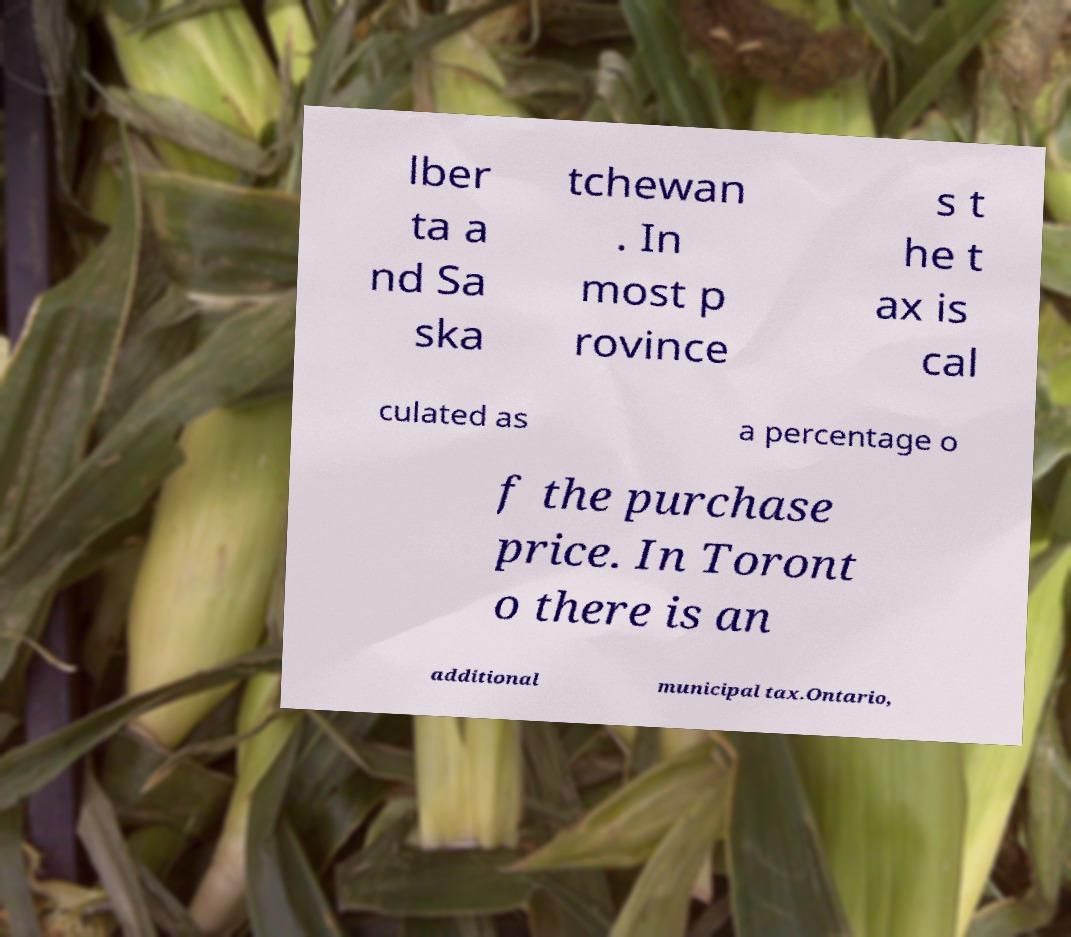Can you read and provide the text displayed in the image?This photo seems to have some interesting text. Can you extract and type it out for me? lber ta a nd Sa ska tchewan . In most p rovince s t he t ax is cal culated as a percentage o f the purchase price. In Toront o there is an additional municipal tax.Ontario, 